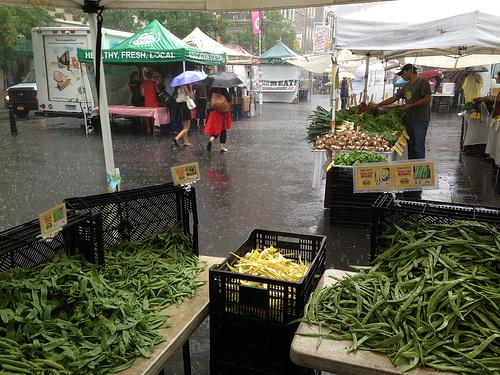Question: what is the umbrella for?
Choices:
A. Shade.
B. Protection.
C. The rain.
D. Looks.
Answer with the letter. Answer: C Question: who is in the picture?
Choices:
A. Dogs.
B. People.
C. Cats.
D. Dolphins.
Answer with the letter. Answer: B Question: what is this place?
Choices:
A. A flea market.
B. A farmers market.
C. A produce stand.
D. A meat market.
Answer with the letter. Answer: B Question: what is the black case?
Choices:
A. A briefcase.
B. A crate.
C. A suitcase.
D. A safe.
Answer with the letter. Answer: B 